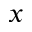<formula> <loc_0><loc_0><loc_500><loc_500>_ { x }</formula> 